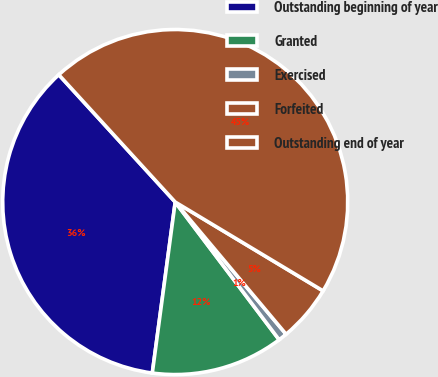Convert chart to OTSL. <chart><loc_0><loc_0><loc_500><loc_500><pie_chart><fcel>Outstanding beginning of year<fcel>Granted<fcel>Exercised<fcel>Forfeited<fcel>Outstanding end of year<nl><fcel>36.09%<fcel>12.41%<fcel>0.82%<fcel>5.28%<fcel>45.4%<nl></chart> 